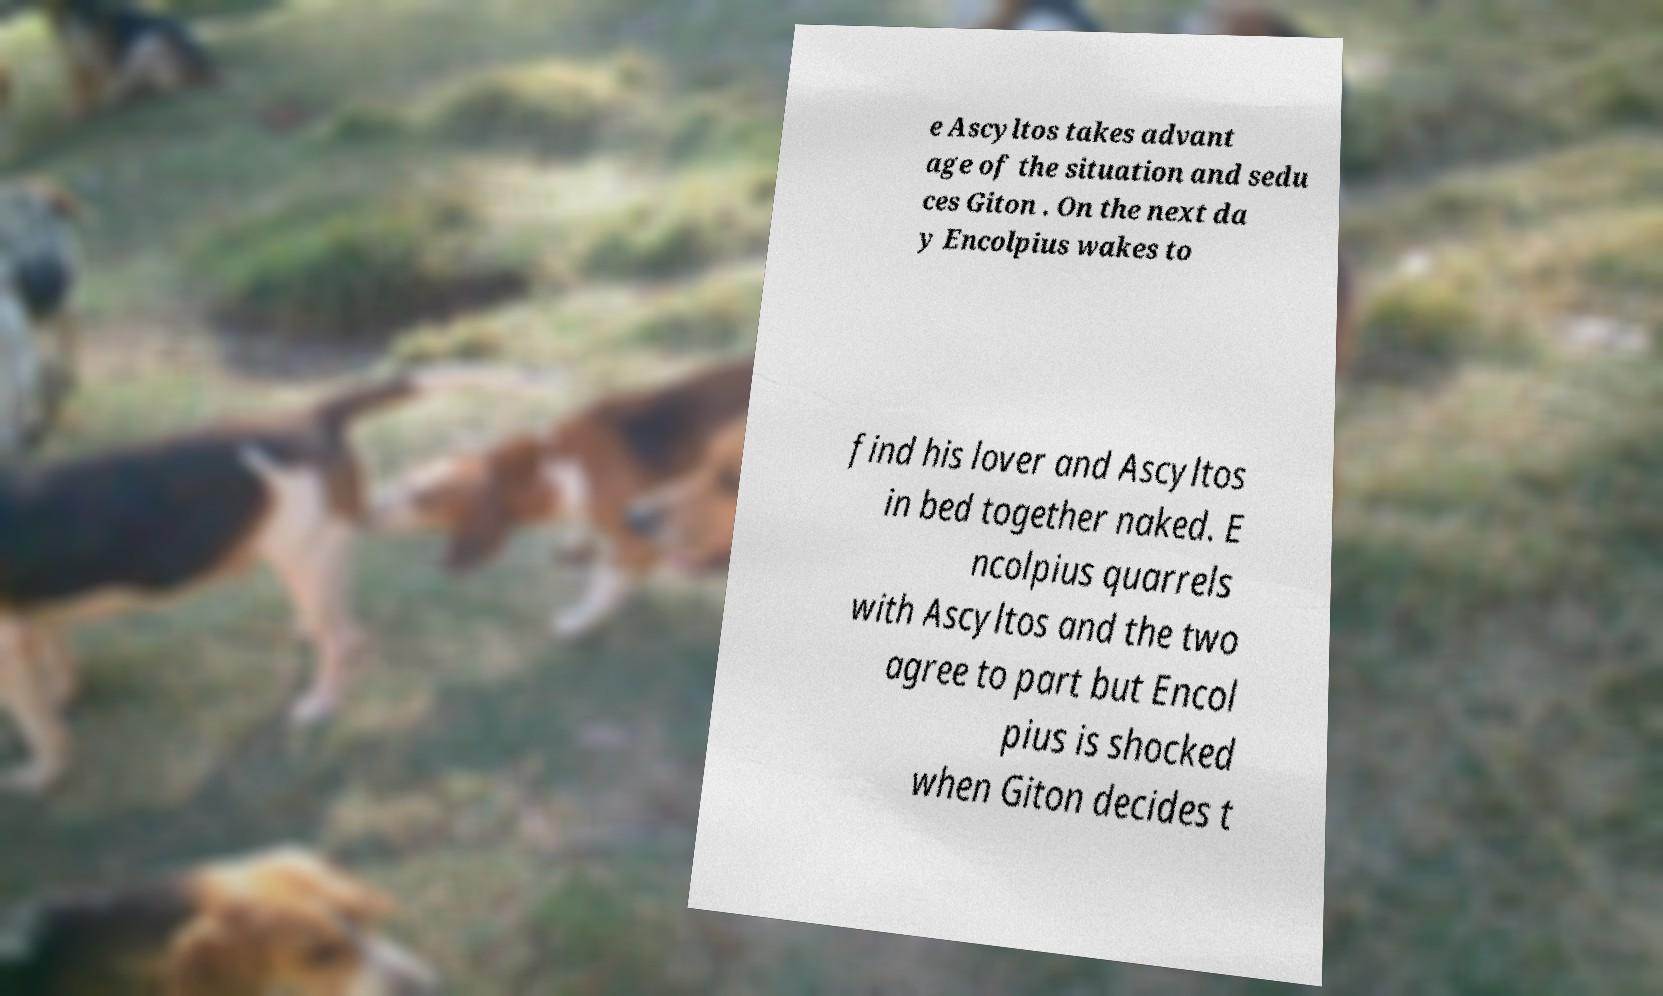There's text embedded in this image that I need extracted. Can you transcribe it verbatim? e Ascyltos takes advant age of the situation and sedu ces Giton . On the next da y Encolpius wakes to find his lover and Ascyltos in bed together naked. E ncolpius quarrels with Ascyltos and the two agree to part but Encol pius is shocked when Giton decides t 